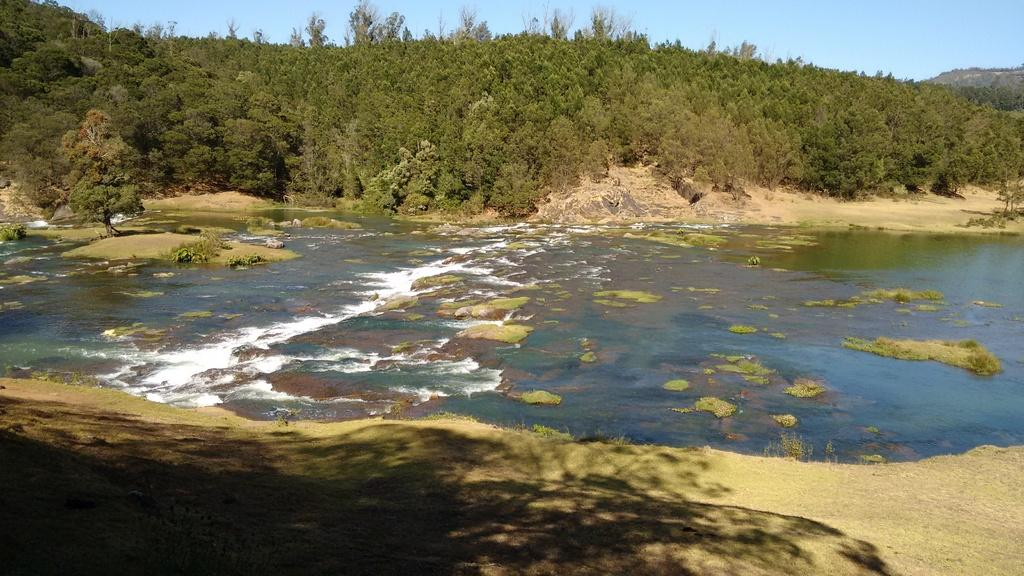What type of natural feature is present in the image? There is a river in the image. What is happening to the water in the river? Water is flowing in the river. What type of geological features can be seen in the image? There are rocks visible in the image. What type of vegetation is present in the image? There is grass and trees in the image. What type of landscape feature is present in the image? There is a hill in the image. What color is the grandmother's dress in the image? There is no grandmother present in the image. 